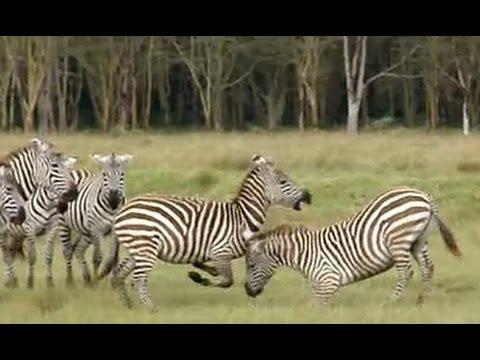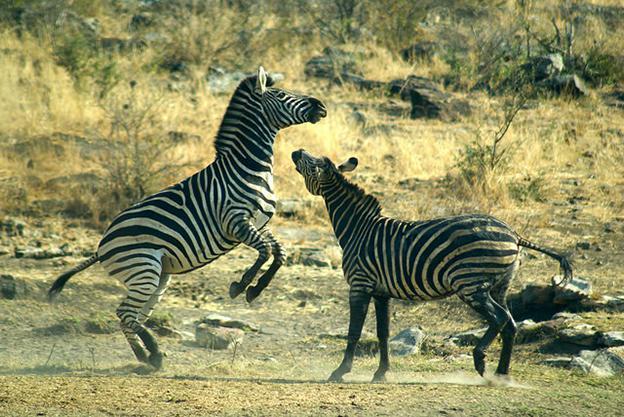The first image is the image on the left, the second image is the image on the right. Given the left and right images, does the statement "Each image contains exactly two zebras, and the left image shows one zebra standing on its hind legs face-to-face and in contact with another zebra." hold true? Answer yes or no. No. 